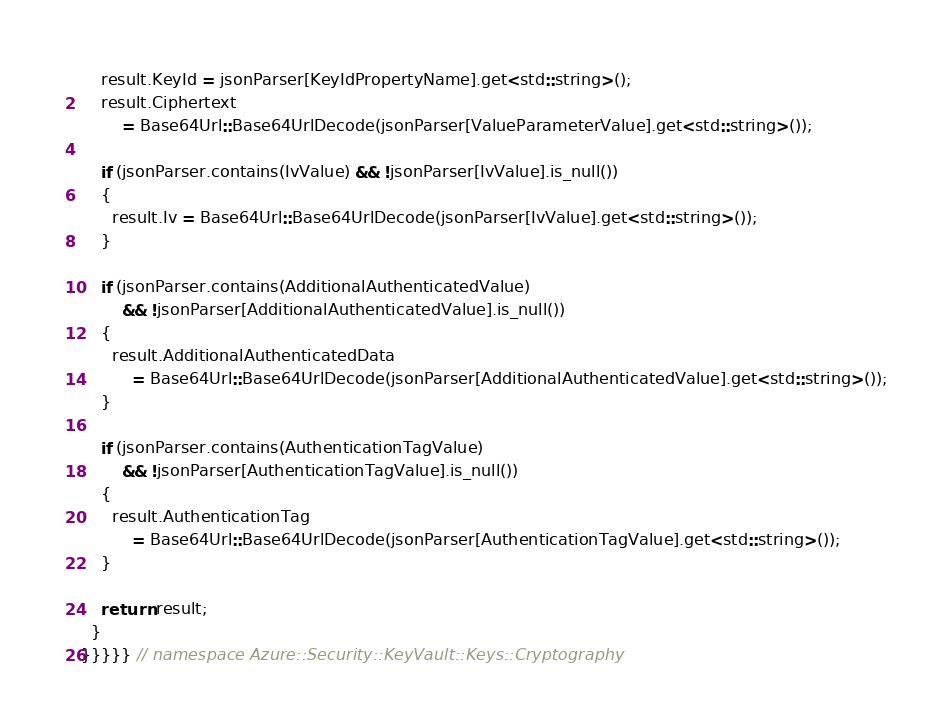<code> <loc_0><loc_0><loc_500><loc_500><_C++_>    result.KeyId = jsonParser[KeyIdPropertyName].get<std::string>();
    result.Ciphertext
        = Base64Url::Base64UrlDecode(jsonParser[ValueParameterValue].get<std::string>());

    if (jsonParser.contains(IvValue) && !jsonParser[IvValue].is_null())
    {
      result.Iv = Base64Url::Base64UrlDecode(jsonParser[IvValue].get<std::string>());
    }

    if (jsonParser.contains(AdditionalAuthenticatedValue)
        && !jsonParser[AdditionalAuthenticatedValue].is_null())
    {
      result.AdditionalAuthenticatedData
          = Base64Url::Base64UrlDecode(jsonParser[AdditionalAuthenticatedValue].get<std::string>());
    }

    if (jsonParser.contains(AuthenticationTagValue)
        && !jsonParser[AuthenticationTagValue].is_null())
    {
      result.AuthenticationTag
          = Base64Url::Base64UrlDecode(jsonParser[AuthenticationTagValue].get<std::string>());
    }

    return result;
  }
}}}}} // namespace Azure::Security::KeyVault::Keys::Cryptography
</code> 